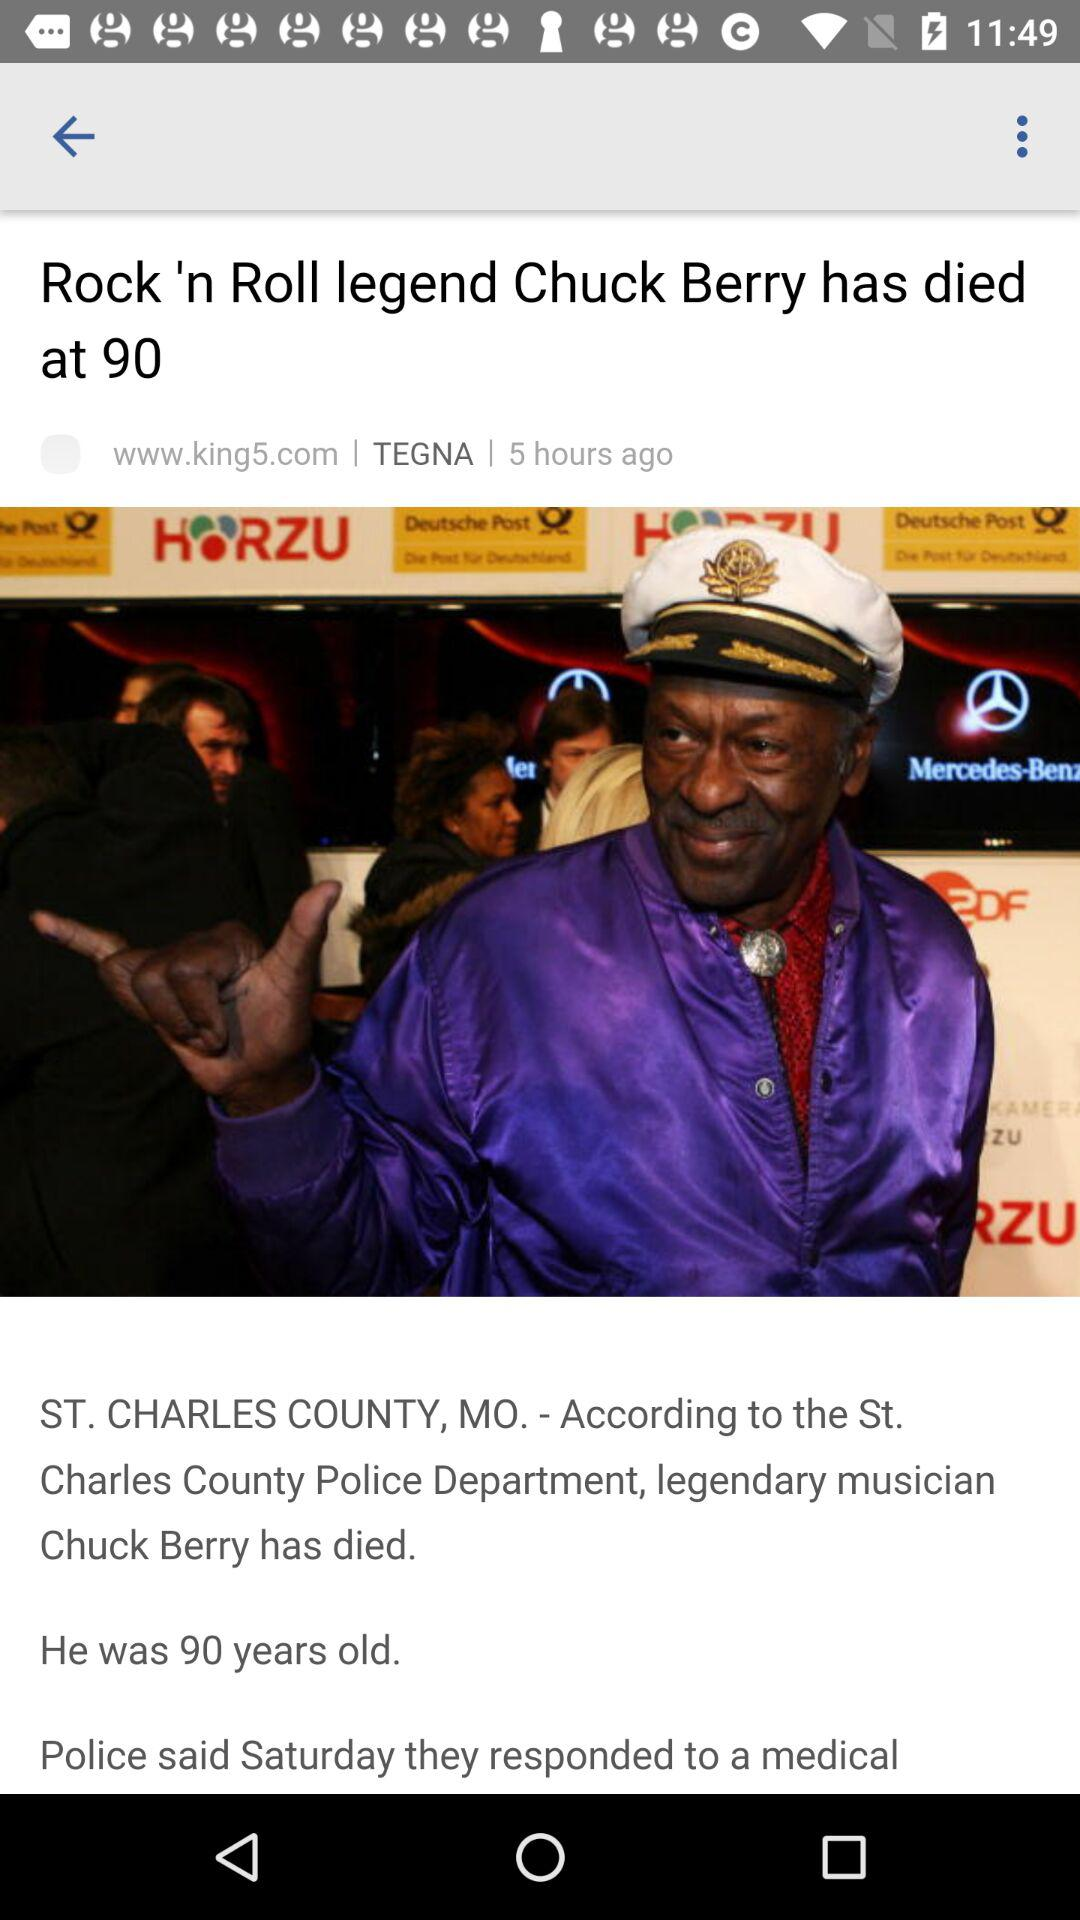Who is the author of this article?
When the provided information is insufficient, respond with <no answer>. <no answer> 